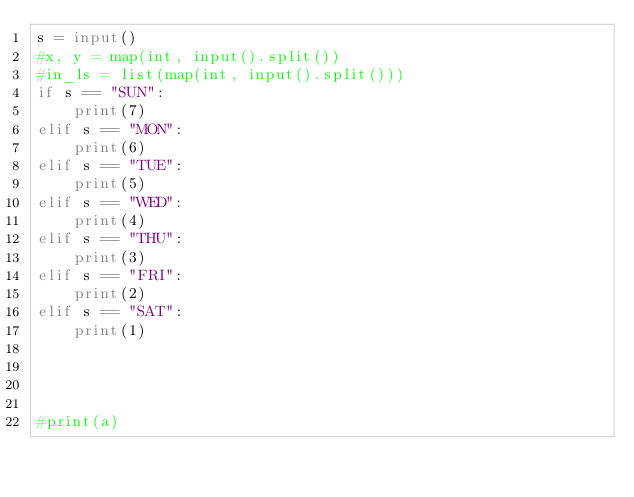Convert code to text. <code><loc_0><loc_0><loc_500><loc_500><_Python_>s = input()
#x, y = map(int, input().split())
#in_ls = list(map(int, input().split()))
if s == "SUN":
    print(7)
elif s == "MON":
    print(6)
elif s == "TUE":
    print(5)
elif s == "WED":
    print(4)
elif s == "THU":
    print(3)
elif s == "FRI":
    print(2)
elif s == "SAT":
    print(1)




#print(a)
</code> 